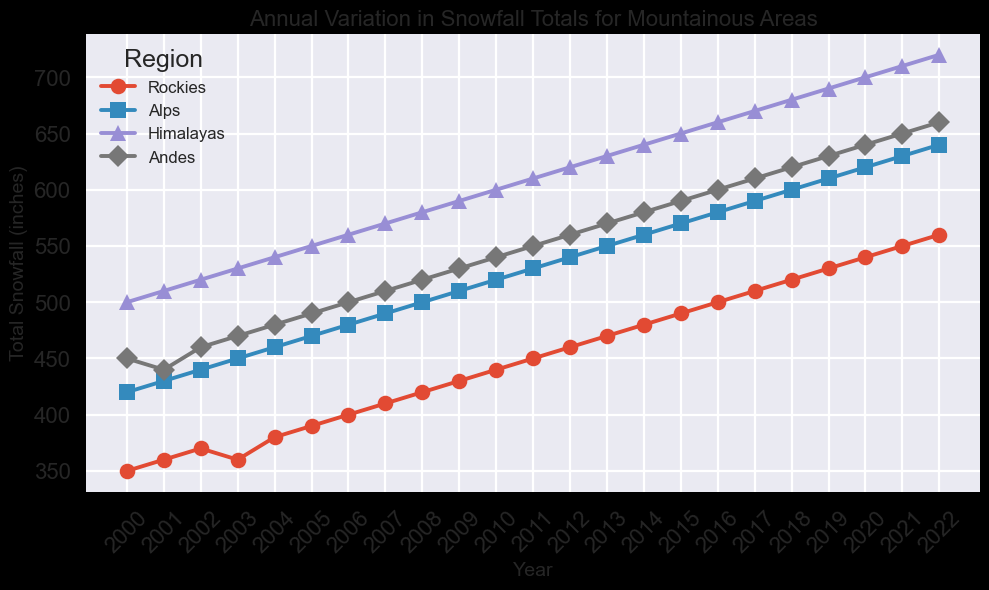Which region has the highest total snowfall in 2022? Look at the endpoint for 2022 on the graph, and identify the region with the highest position on the y-axis. The Himalayas have the highest total snowfall in 2022 as their line reaches the highest point.
Answer: Himalayas How did the total snowfall in the Andes change from 2000 to 2022? Look at the line representing the Andes from the start (2000) to the end (2022). Observe the starting and ending values of the line. The snowfall increased from 450 inches in 2000 to 660 inches in 2022.
Answer: Increased by 210 inches What’s the difference in total snowfall between the Rockies and the Alps in 2010? Observe the lines in the year 2010 for both the Rockies and Alps. Subtract the total snowfall value of the Rockies from that of the Alps (520 - 440).
Answer: 80 inches Which region had the least variation in annual snowfall totals over the years? Analyze the lines of each region and see which line appears the least fluctuating or has a steadier trend compared to others. The Rockies show a more gradual increase compared to other regions, indicating less variation.
Answer: Rockies In what year did the Alps and the Andes have the same total snowfall? Locate the point where the lines representing the Alps and the Andes intersect. The intersection occurs in 2001.
Answer: 2001 What is the average total snowfall of the Himalayas over the period 2000-2022? Sum all the annual snowfall totals for the Himalayas over the period, then divide by the number of years (23). The total sum is 15490 inches. Average = 15490 / 23 = 673.
Answer: 673 inches Which region showed the most consistent annual increase in snowfall totals? Look for the region whose line shows the most consistent upward trend without significant fluctuations. The Himalayas show a steady increase each year.
Answer: Himalayas Between which years did the Rockies see the highest increase in snowfall totals? Look for the period where the slope of the Rockies' line is the steepest upward. The values show a notable increase from 2016 (500 inches) to 2017 (510 inches), making it the highest increase of 10 inches in one year.
Answer: 2016 to 2017 How does the snowfall trend of the Alps compare to that of the Andes from 2005 to 2015? Compare the slopes of the lines representing the Alps and the Andes between 2005 to 2015. Both regions show an upward trend, but the total increase for the Alps is from 470 to 570, while the Andes increase from 490 to 590, meaning both regions have similar trends but the Andes have slightly higher values overall.
Answer: Similar upward trend What was the total increase in snowfall for the Himalayas from 2000 to 2022? Subtract the total snowfall in 2000 from the total in 2022 for the Himalayas (720-500).
Answer: 220 inches 